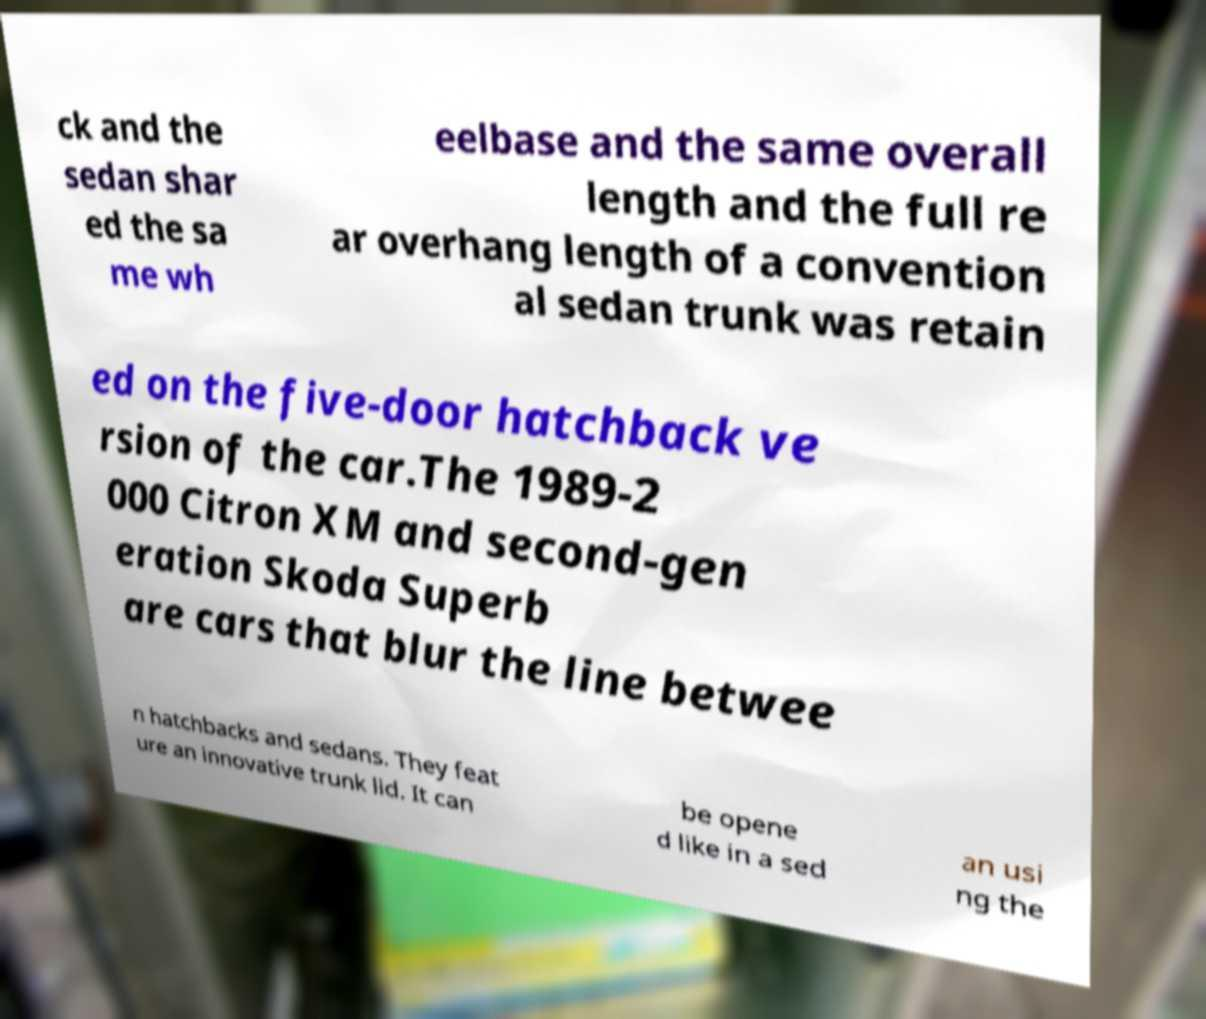What messages or text are displayed in this image? I need them in a readable, typed format. ck and the sedan shar ed the sa me wh eelbase and the same overall length and the full re ar overhang length of a convention al sedan trunk was retain ed on the five-door hatchback ve rsion of the car.The 1989-2 000 Citron XM and second-gen eration Skoda Superb are cars that blur the line betwee n hatchbacks and sedans. They feat ure an innovative trunk lid. It can be opene d like in a sed an usi ng the 